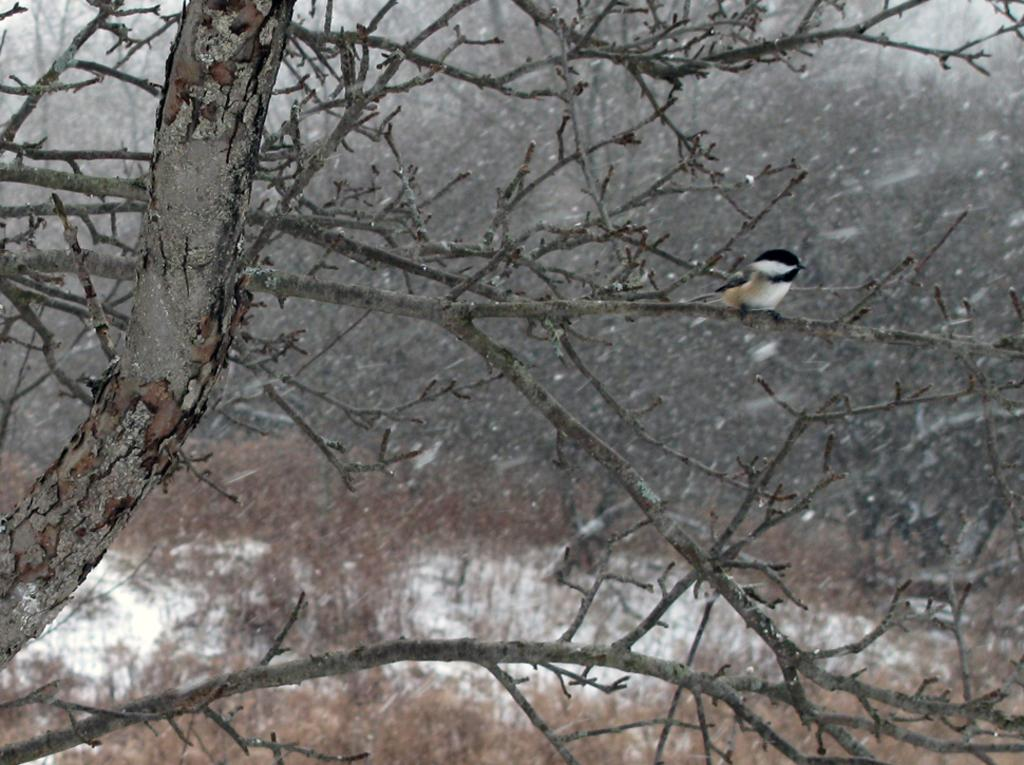What type of animal can be seen in the image? There is a bird in the image. Where is the bird located? The bird is standing on a tree branch. What can be seen in the background of the image? There are many trees in the background of the image. What is the ground made of at the bottom of the image? Snow and grass are present at the bottom of the image. What type of party is the bird attending in the image? There is no party present in the image, and the bird is not attending any event. What cast member from a popular TV show can be seen in the image? There are no cast members or TV shows mentioned in the image; it only features a bird on a tree branch. 